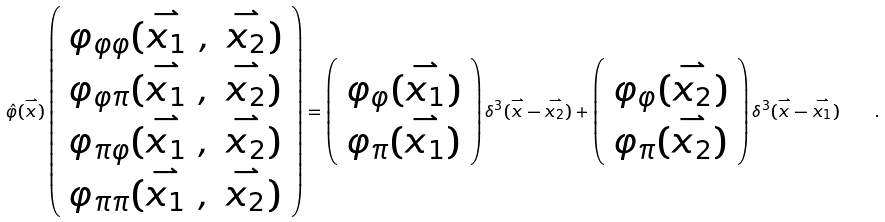Convert formula to latex. <formula><loc_0><loc_0><loc_500><loc_500>\hat { \varphi } ( \stackrel { \rightharpoonup } { x } ) \left ( \begin{array} { l } { { \varphi _ { \varphi \varphi } ( \stackrel { \rightharpoonup } { x _ { 1 } } \ , \ \stackrel { \rightharpoonup } { x _ { 2 } } ) } } \\ { { \varphi _ { \varphi \pi } ( \stackrel { \rightharpoonup } { x _ { 1 } } \ , \ \stackrel { \rightharpoonup } { x _ { 2 } } ) } } \\ { { \varphi _ { \pi \varphi } ( \stackrel { \rightharpoonup } { x _ { 1 } } \ , \ \stackrel { \rightharpoonup } { x _ { 2 } } ) } } \\ { { \varphi _ { \pi \pi } ( \stackrel { \rightharpoonup } { x _ { 1 } } \ , \ \stackrel { \rightharpoonup } { x _ { 2 } } ) } } \end{array} \right ) = \left ( \begin{array} { l } { { \varphi _ { \varphi } ( \stackrel { \rightharpoonup } { x _ { 1 } } ) } } \\ { { \varphi _ { \pi } ( \stackrel { \rightharpoonup } { x _ { 1 } } ) } } \end{array} \right ) \delta ^ { 3 } ( \stackrel { \rightharpoonup } { x } - \stackrel { \rightharpoonup } { x _ { 2 } } ) + \left ( \begin{array} { l } { { \varphi _ { \varphi } ( \stackrel { \rightharpoonup } { x _ { 2 } } ) } } \\ { { \varphi _ { \pi } ( \stackrel { \rightharpoonup } { x _ { 2 } } ) } } \end{array} \right ) \delta ^ { 3 } ( \stackrel { \rightharpoonup } { x } - \stackrel { \rightharpoonup } { x _ { 1 } } ) \quad .</formula> 